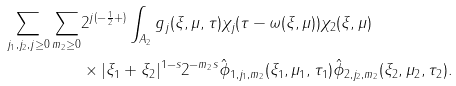Convert formula to latex. <formula><loc_0><loc_0><loc_500><loc_500>\sum _ { j _ { 1 } , j _ { 2 } , j \geq 0 } \sum _ { m _ { 2 } \geq 0 } & 2 ^ { j ( - \frac { 1 } { 2 } + ) } \int _ { A _ { 2 } } g _ { j } ( \xi , \mu , \tau ) \chi _ { j } ( \tau - \omega ( \xi , \mu ) ) \chi _ { 2 } ( \xi , \mu ) \\ & \times | \xi _ { 1 } + \xi _ { 2 } | ^ { 1 - s } 2 ^ { - m _ { 2 } s } \hat { \phi } _ { 1 , j _ { 1 } , m _ { 2 } } ( \xi _ { 1 } , \mu _ { 1 } , \tau _ { 1 } ) \hat { \phi } _ { 2 , j _ { 2 } , m _ { 2 } } ( \xi _ { 2 } , \mu _ { 2 } , \tau _ { 2 } ) .</formula> 